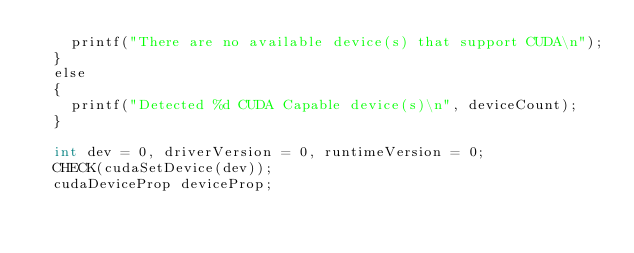<code> <loc_0><loc_0><loc_500><loc_500><_Cuda_>		printf("There are no available device(s) that support CUDA\n");
	}
	else
	{
		printf("Detected %d CUDA Capable device(s)\n", deviceCount);
	}

	int dev = 0, driverVersion = 0, runtimeVersion = 0;
	CHECK(cudaSetDevice(dev));
	cudaDeviceProp deviceProp;</code> 